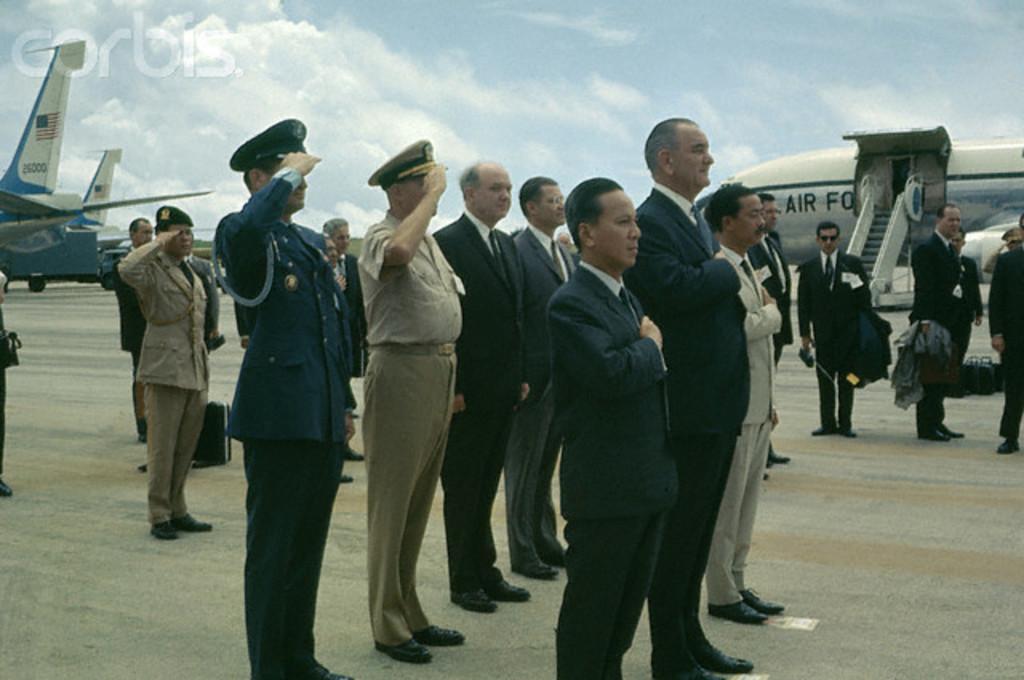Describe this image in one or two sentences. In this picture we can see a group of people standing on the path and behind the people there are airplanes and a cloudy sky. On the image there is a watermark. 